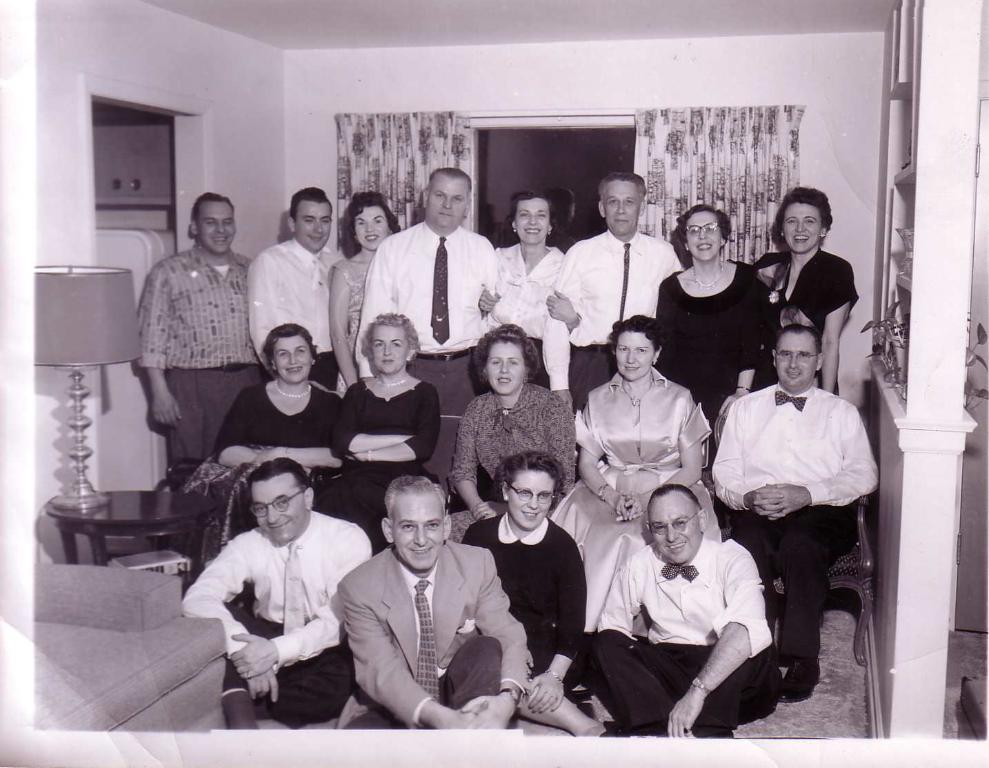In one or two sentences, can you explain what this image depicts? Here we can see that a group of people standing and some are sitting on the floor, and at back here is the curtain, and here is the wall, and here is the table and lamp on it. 